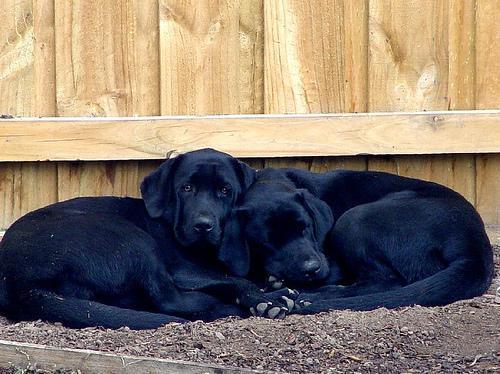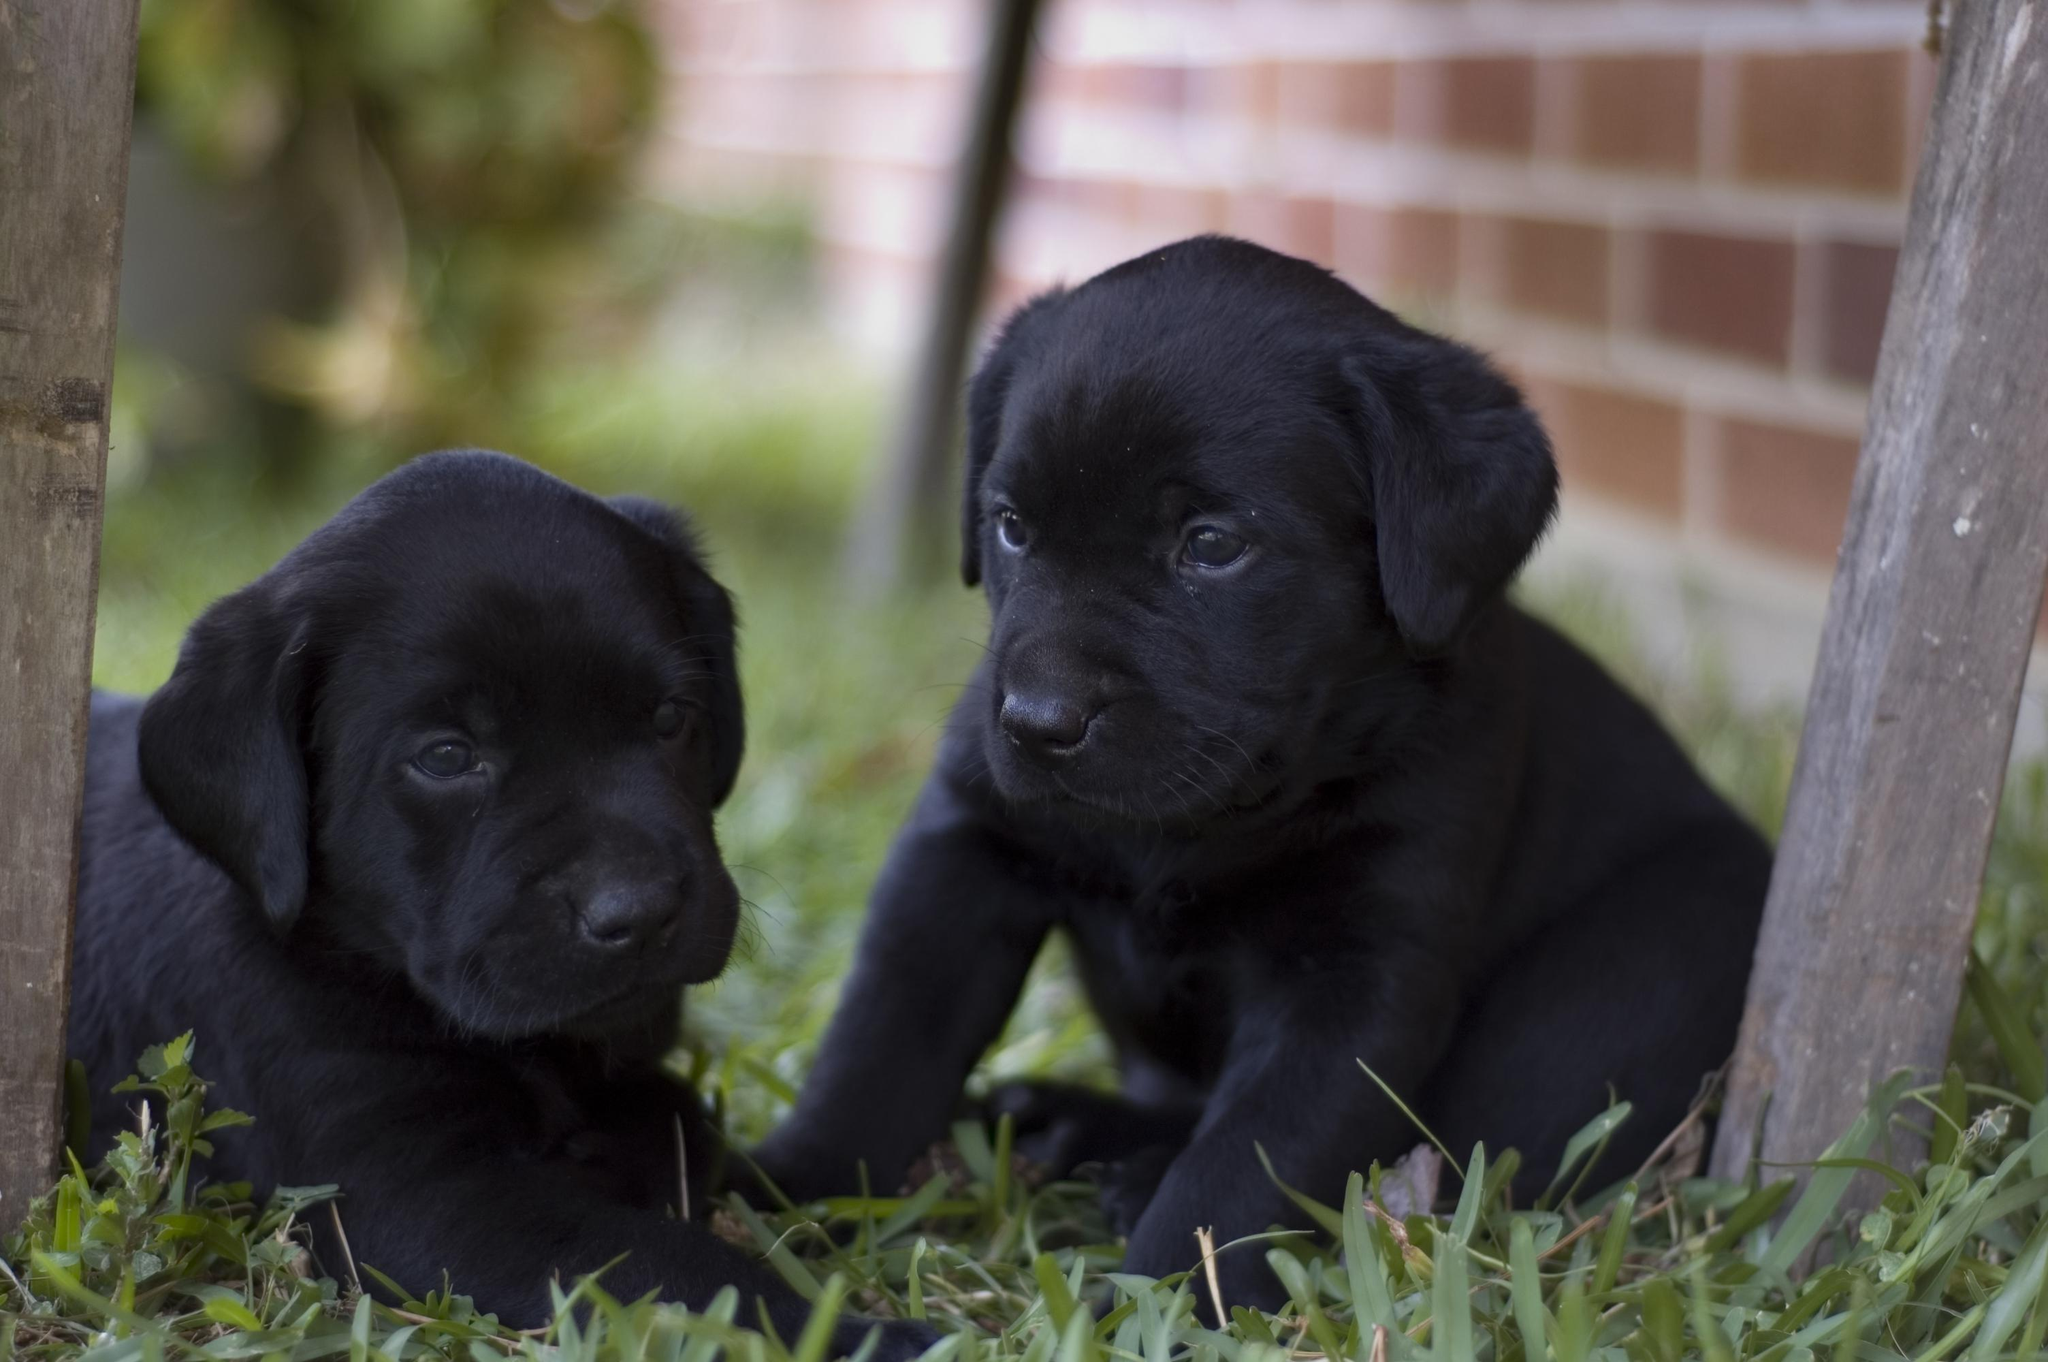The first image is the image on the left, the second image is the image on the right. Evaluate the accuracy of this statement regarding the images: "A dog is lying on a couch with its head down.". Is it true? Answer yes or no. No. The first image is the image on the left, the second image is the image on the right. Given the left and right images, does the statement "An image shows two dogs reclining together on something indoors, with a white fabric under them." hold true? Answer yes or no. No. 